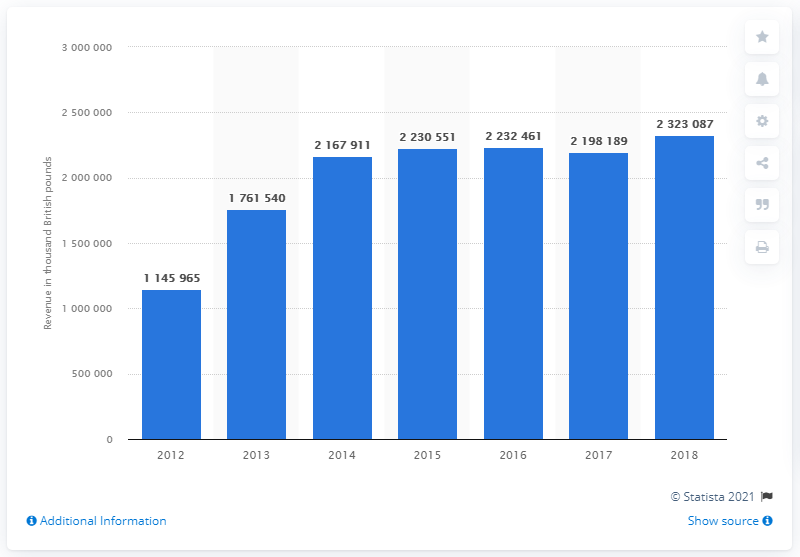Indicate a few pertinent items in this graphic. The chart compared data from seven years. The average of the first three years of data is 1691805. 